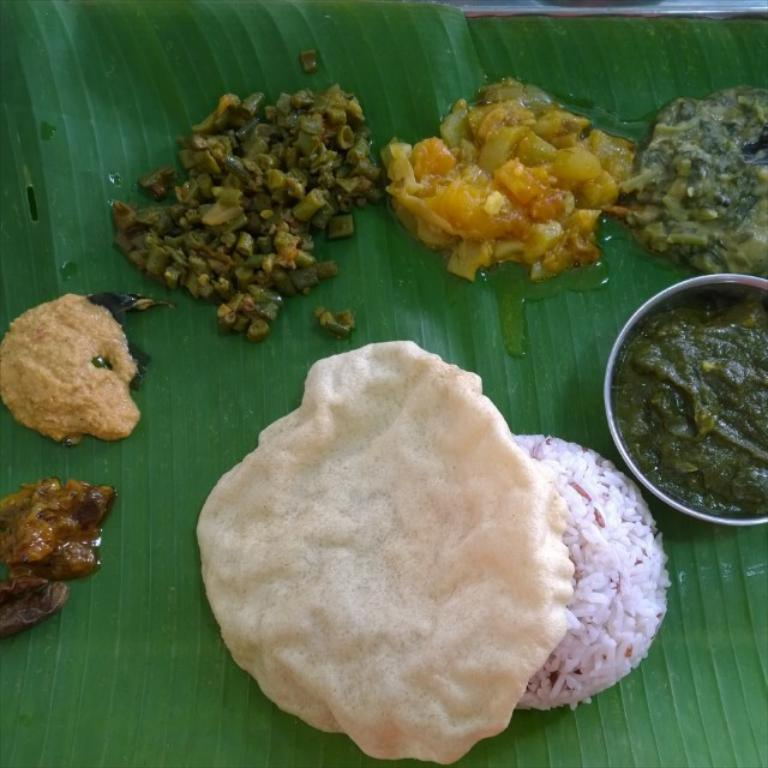What type of food is visible in the image? The image contains curries and rice. How is the food arranged in the image? The food is placed on a banana leaf. Is there any food in a container in the image? Yes, there is food in a bowl in the image. What type of trouble is the kitten causing in the image? There is no kitten present in the image, so it cannot be causing any trouble. 